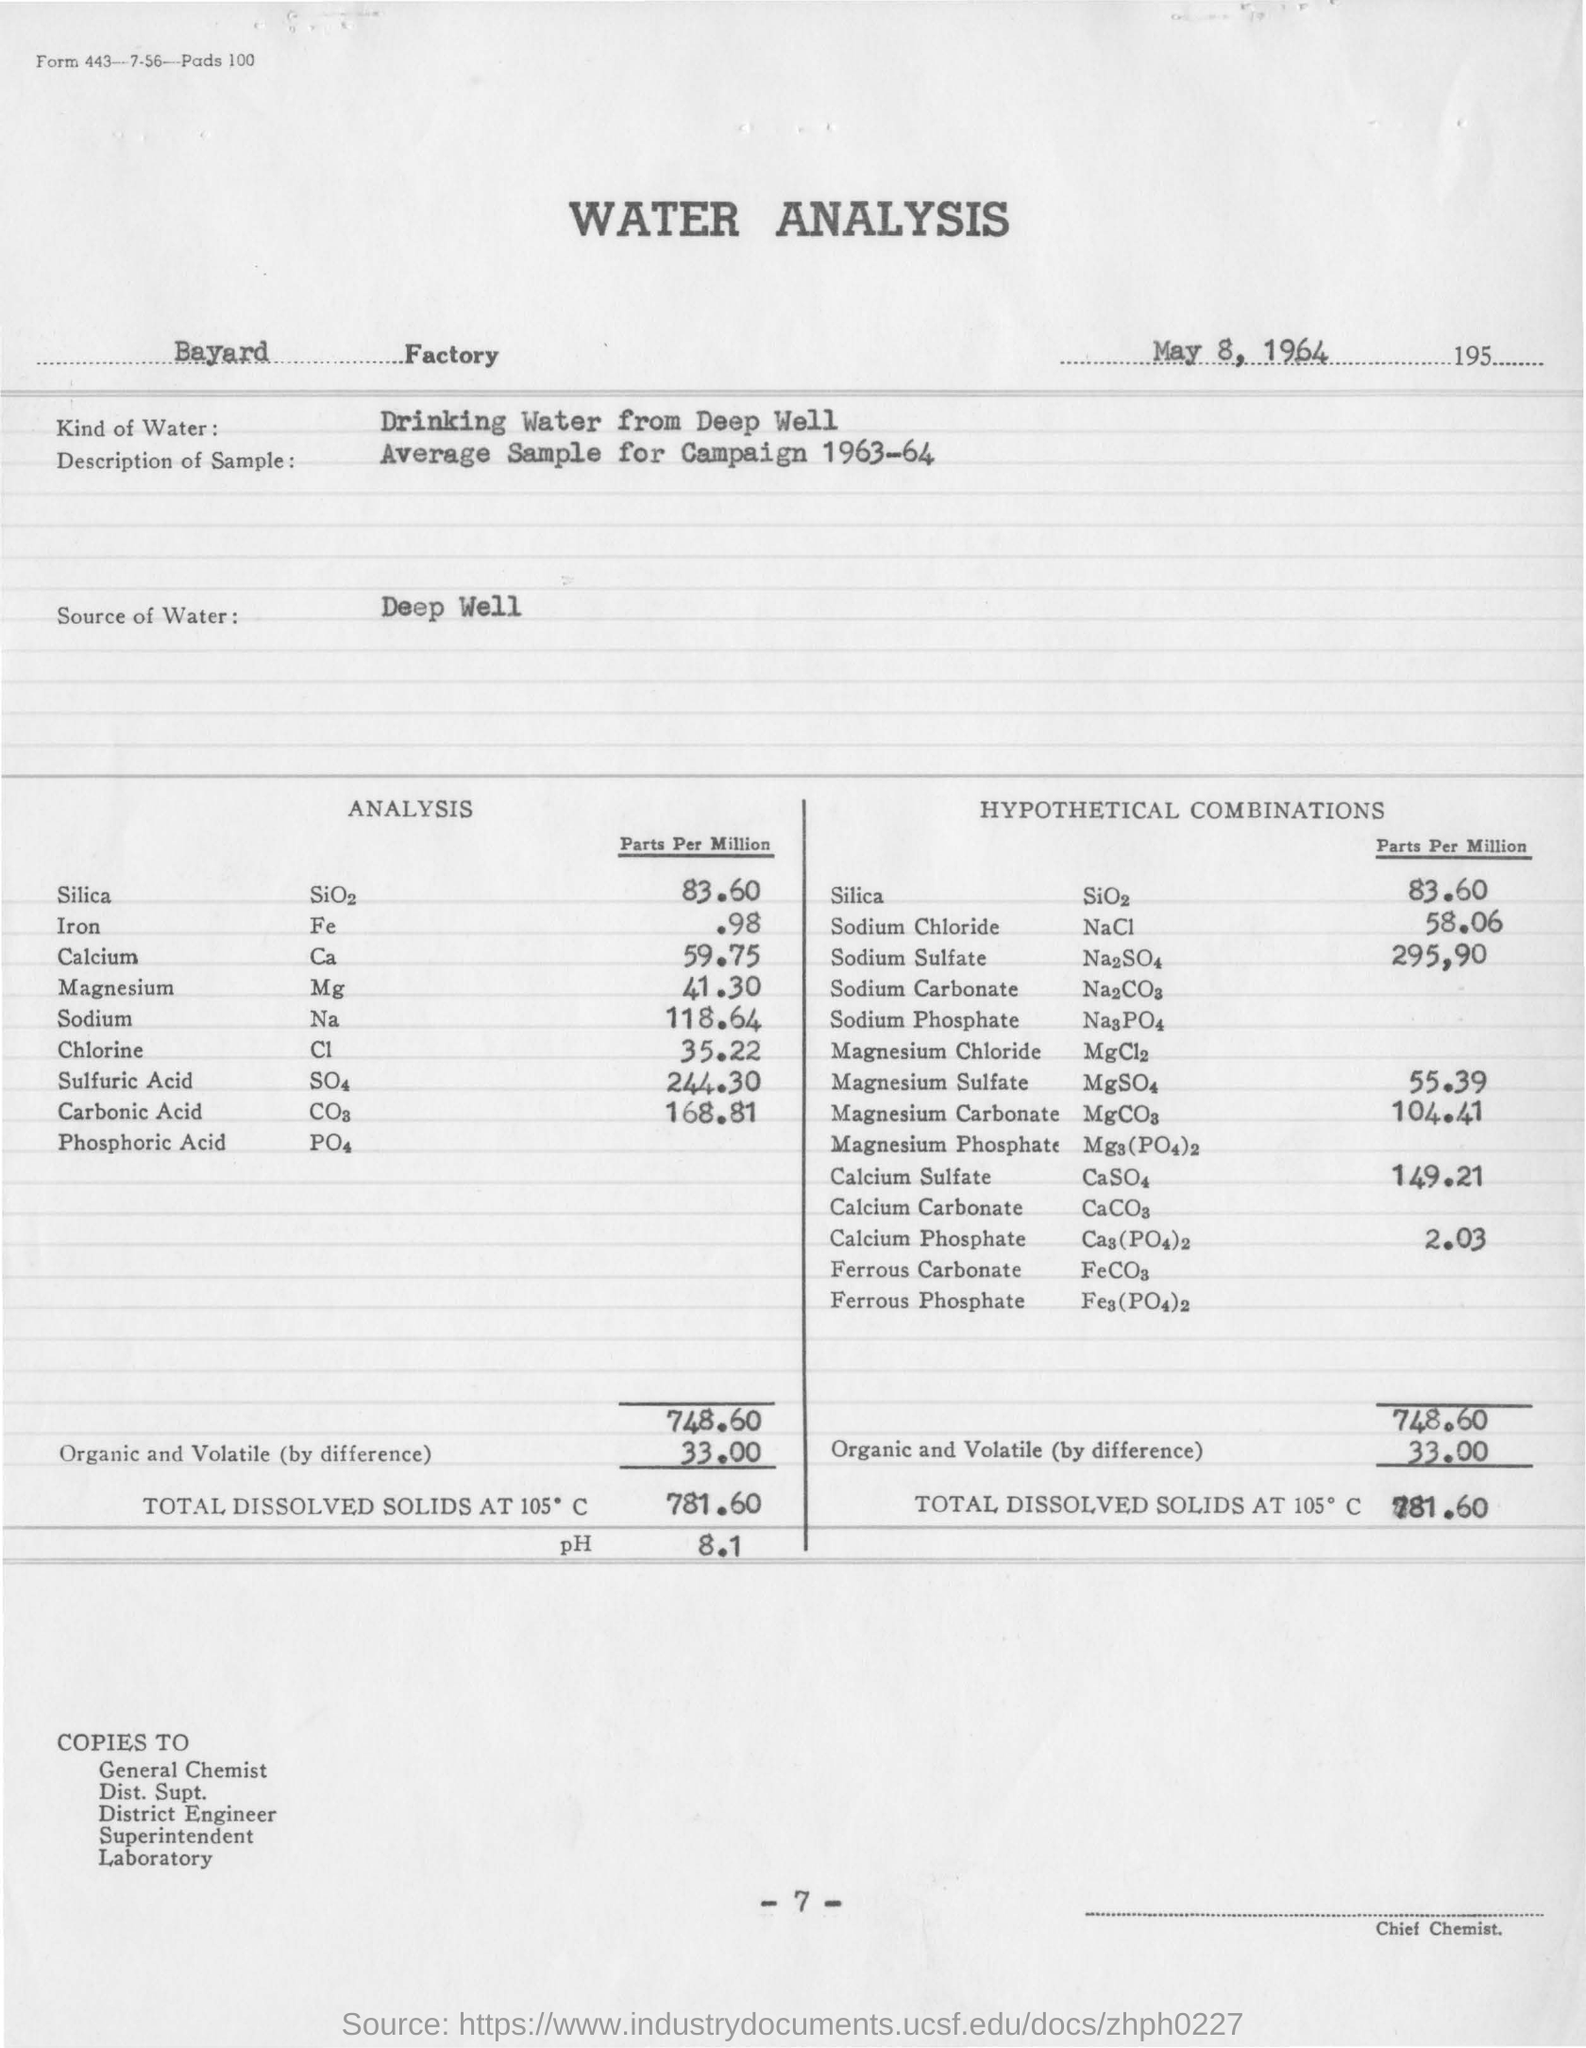What kind of water is used in water analysis?
Your response must be concise. Drinking water from deep well. In which factory the water analysis is conducted ?
Provide a short and direct response. Bayard factory. On which date the water analysis is conducted ?
Offer a terse response. May 8, 1964. What is the parts per million value of iron in analysis ?
Your answer should be very brief. .98. What is the ph value obtained in the water analysis ?
Your answer should be very brief. 8.1. What is the value of organic and volatile (by difference)?
Ensure brevity in your answer.  33.00. What is the amount of total dissolved solids at 105 degrees c ?
Make the answer very short. 781.60. 